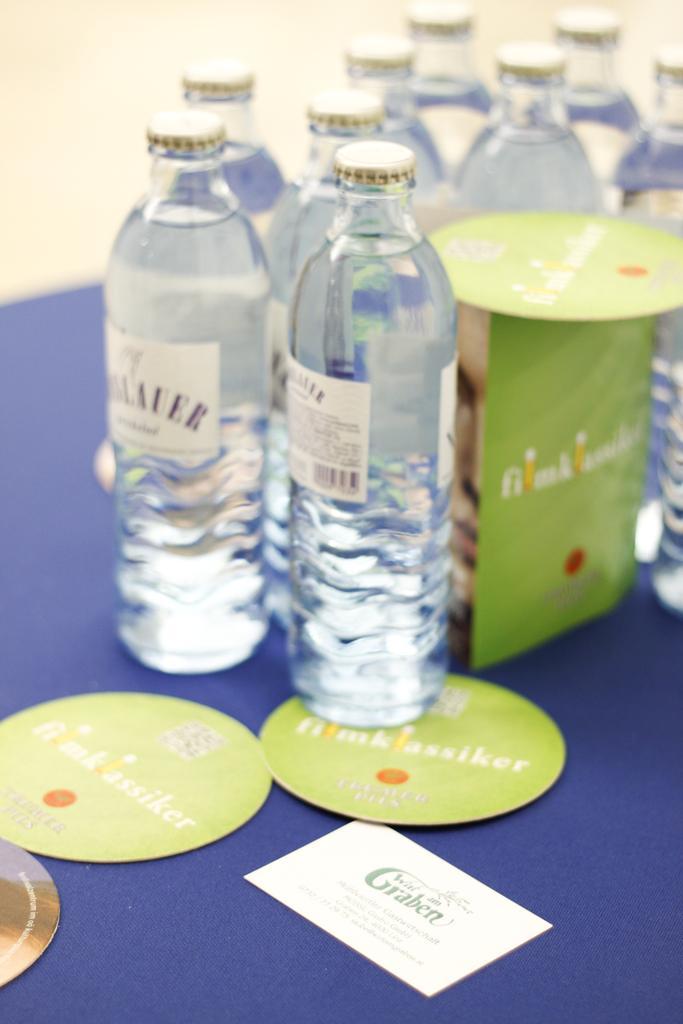Describe this image in one or two sentences. In this picture we can see bottles, cards placed on a floor. 